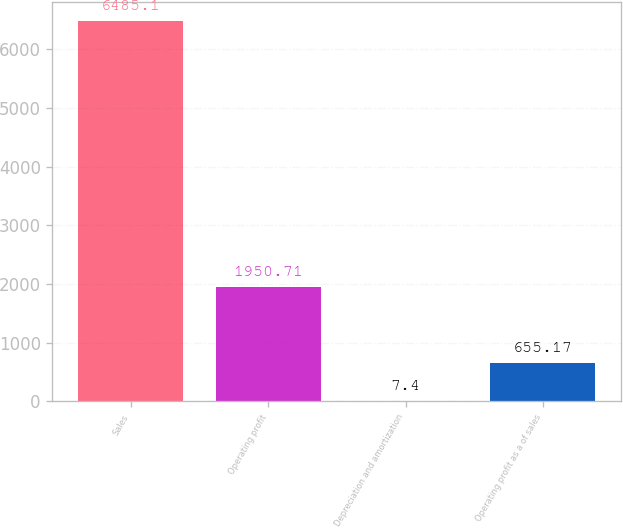Convert chart. <chart><loc_0><loc_0><loc_500><loc_500><bar_chart><fcel>Sales<fcel>Operating profit<fcel>Depreciation and amortization<fcel>Operating profit as a of sales<nl><fcel>6485.1<fcel>1950.71<fcel>7.4<fcel>655.17<nl></chart> 